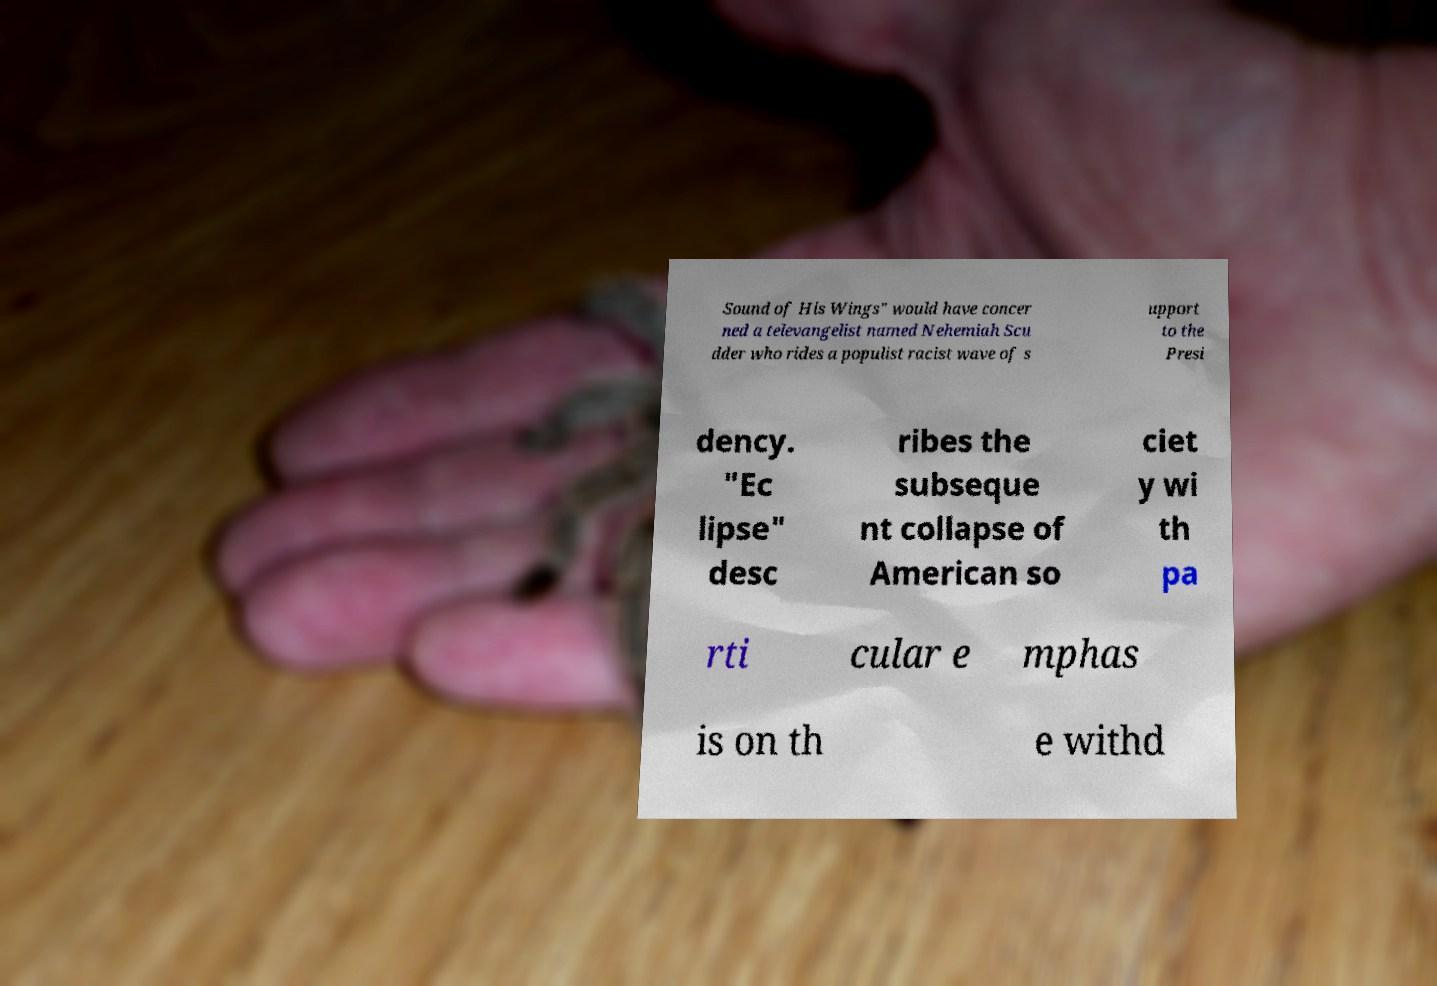Please read and relay the text visible in this image. What does it say? Sound of His Wings" would have concer ned a televangelist named Nehemiah Scu dder who rides a populist racist wave of s upport to the Presi dency. "Ec lipse" desc ribes the subseque nt collapse of American so ciet y wi th pa rti cular e mphas is on th e withd 